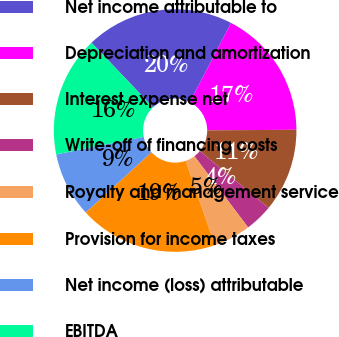<chart> <loc_0><loc_0><loc_500><loc_500><pie_chart><fcel>Net income attributable to<fcel>Depreciation and amortization<fcel>Interest expense net<fcel>Write-off of financing costs<fcel>Royalty and management service<fcel>Provision for income taxes<fcel>Net income (loss) attributable<fcel>EBITDA<nl><fcel>19.74%<fcel>17.27%<fcel>11.11%<fcel>3.72%<fcel>4.96%<fcel>18.51%<fcel>8.65%<fcel>16.04%<nl></chart> 